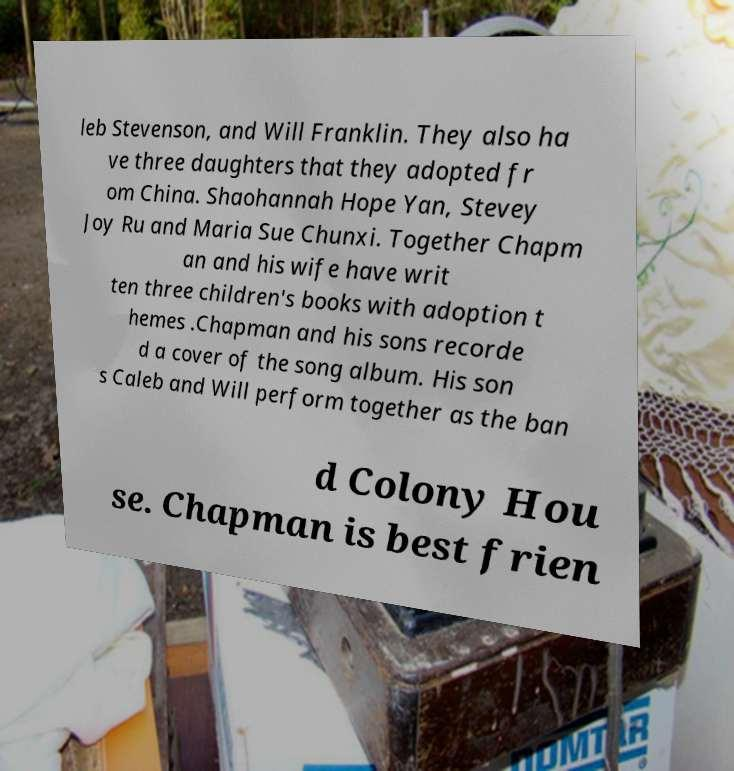What messages or text are displayed in this image? I need them in a readable, typed format. leb Stevenson, and Will Franklin. They also ha ve three daughters that they adopted fr om China. Shaohannah Hope Yan, Stevey Joy Ru and Maria Sue Chunxi. Together Chapm an and his wife have writ ten three children's books with adoption t hemes .Chapman and his sons recorde d a cover of the song album. His son s Caleb and Will perform together as the ban d Colony Hou se. Chapman is best frien 